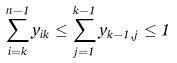<formula> <loc_0><loc_0><loc_500><loc_500>\sum _ { i = k } ^ { n - 1 } y _ { i k } \leq \sum _ { j = 1 } ^ { k - 1 } y _ { k - 1 , j } \leq 1</formula> 